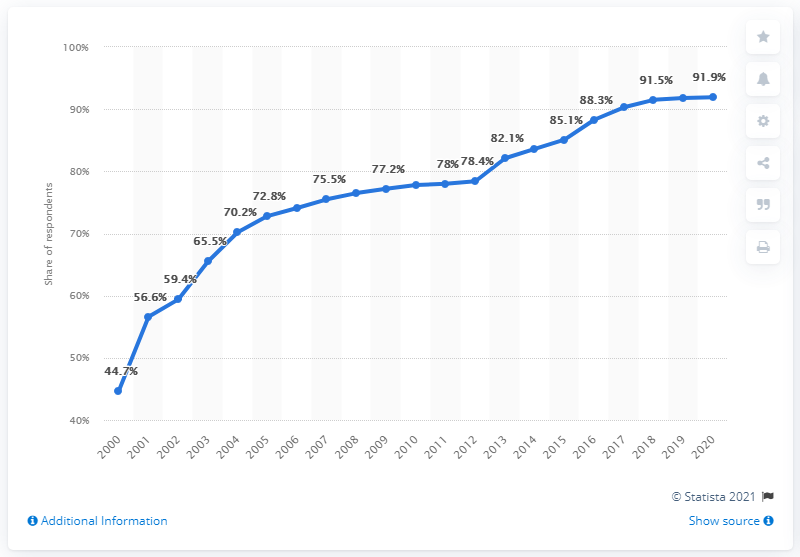Identify some key points in this picture. In South Korea, the internet usage rate among individuals aged 3 years and older was 91.9%. 